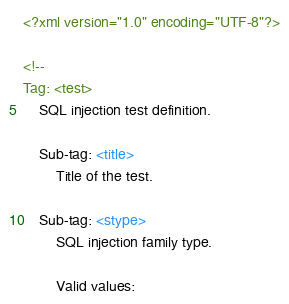<code> <loc_0><loc_0><loc_500><loc_500><_XML_><?xml version="1.0" encoding="UTF-8"?>

<!--
Tag: <test>
    SQL injection test definition.

    Sub-tag: <title>
        Title of the test.

    Sub-tag: <stype>
        SQL injection family type.

        Valid values:</code> 